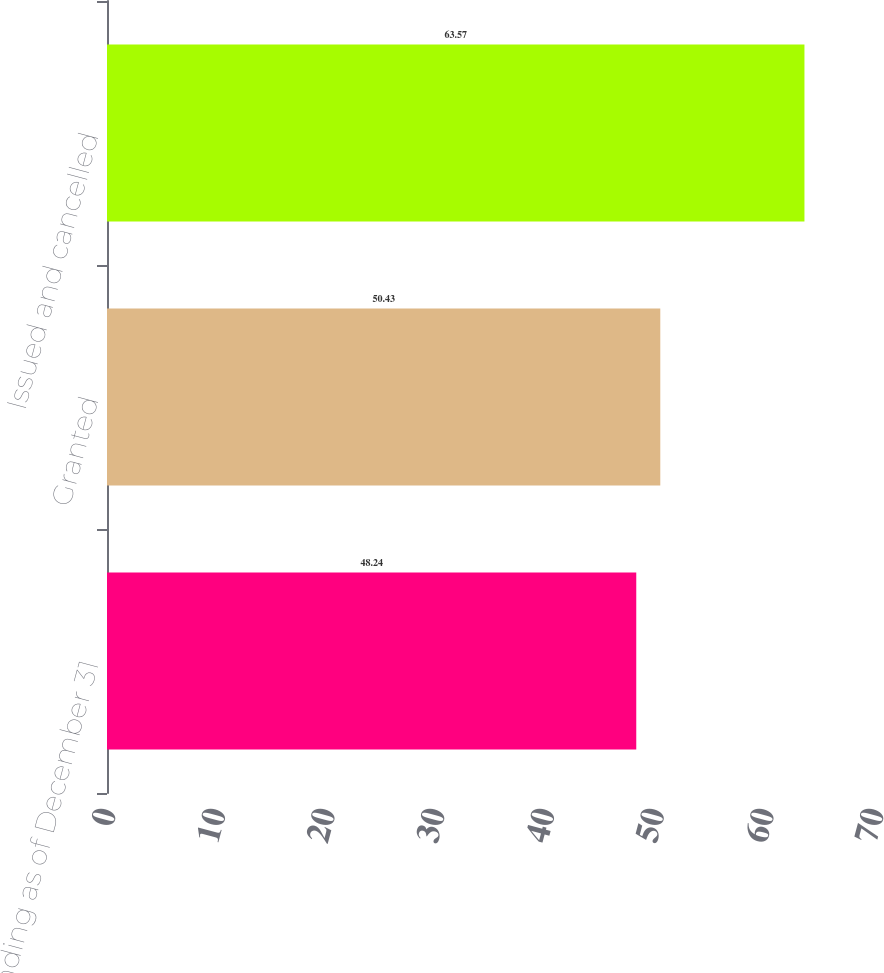Convert chart. <chart><loc_0><loc_0><loc_500><loc_500><bar_chart><fcel>Outstanding as of December 31<fcel>Granted<fcel>Issued and cancelled<nl><fcel>48.24<fcel>50.43<fcel>63.57<nl></chart> 